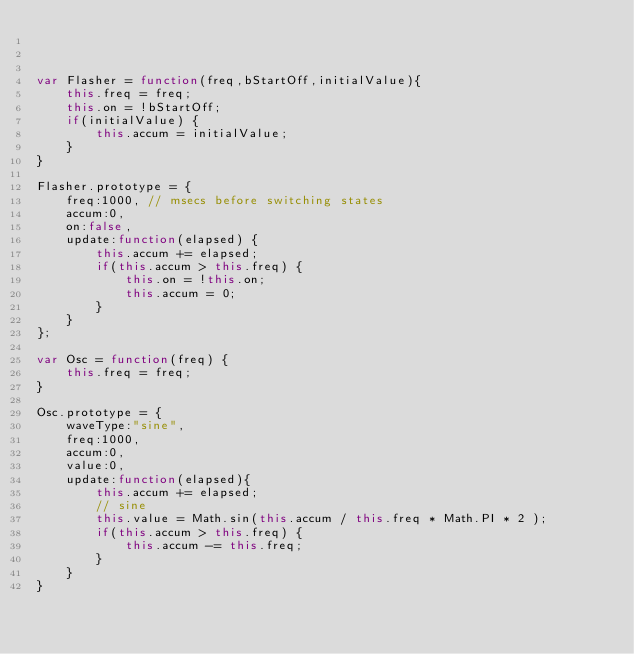<code> <loc_0><loc_0><loc_500><loc_500><_JavaScript_> 


var Flasher = function(freq,bStartOff,initialValue){
	this.freq = freq;
	this.on = !bStartOff;
	if(initialValue) {
		this.accum = initialValue;
	}
}

Flasher.prototype = {
	freq:1000, // msecs before switching states
	accum:0,
	on:false,
	update:function(elapsed) {
		this.accum += elapsed;
		if(this.accum > this.freq) {
			this.on = !this.on;
			this.accum = 0; 
		}
	}	
};

var Osc = function(freq) {
	this.freq = freq;
}

Osc.prototype = {
	waveType:"sine",
	freq:1000,
	accum:0,
	value:0,
	update:function(elapsed){
		this.accum += elapsed;
		// sine
		this.value = Math.sin(this.accum / this.freq * Math.PI * 2 );
		if(this.accum > this.freq) {
			this.accum -= this.freq;
		}
	}
}</code> 